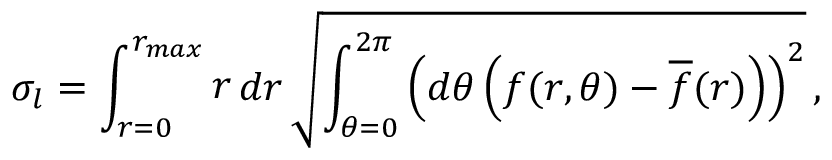Convert formula to latex. <formula><loc_0><loc_0><loc_500><loc_500>\sigma _ { l } = \int _ { r = 0 } ^ { r _ { \max } } r d r \sqrt { \int _ { \theta = 0 } ^ { 2 \pi } \left ( d \theta \left ( f ( r , \theta ) - \overline { f } ( r ) \right ) \right ) ^ { 2 } } \, ,</formula> 